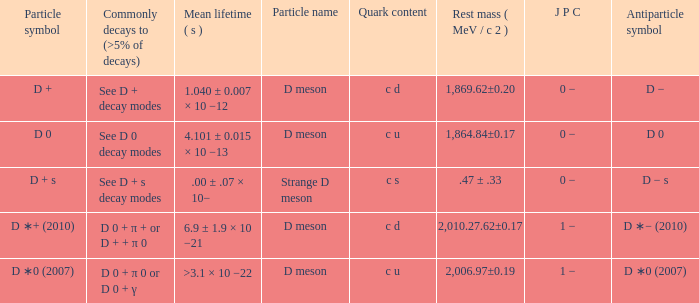What is the j p c that commonly decays (>5% of decays) d 0 + π 0 or d 0 + γ? 1 −. 